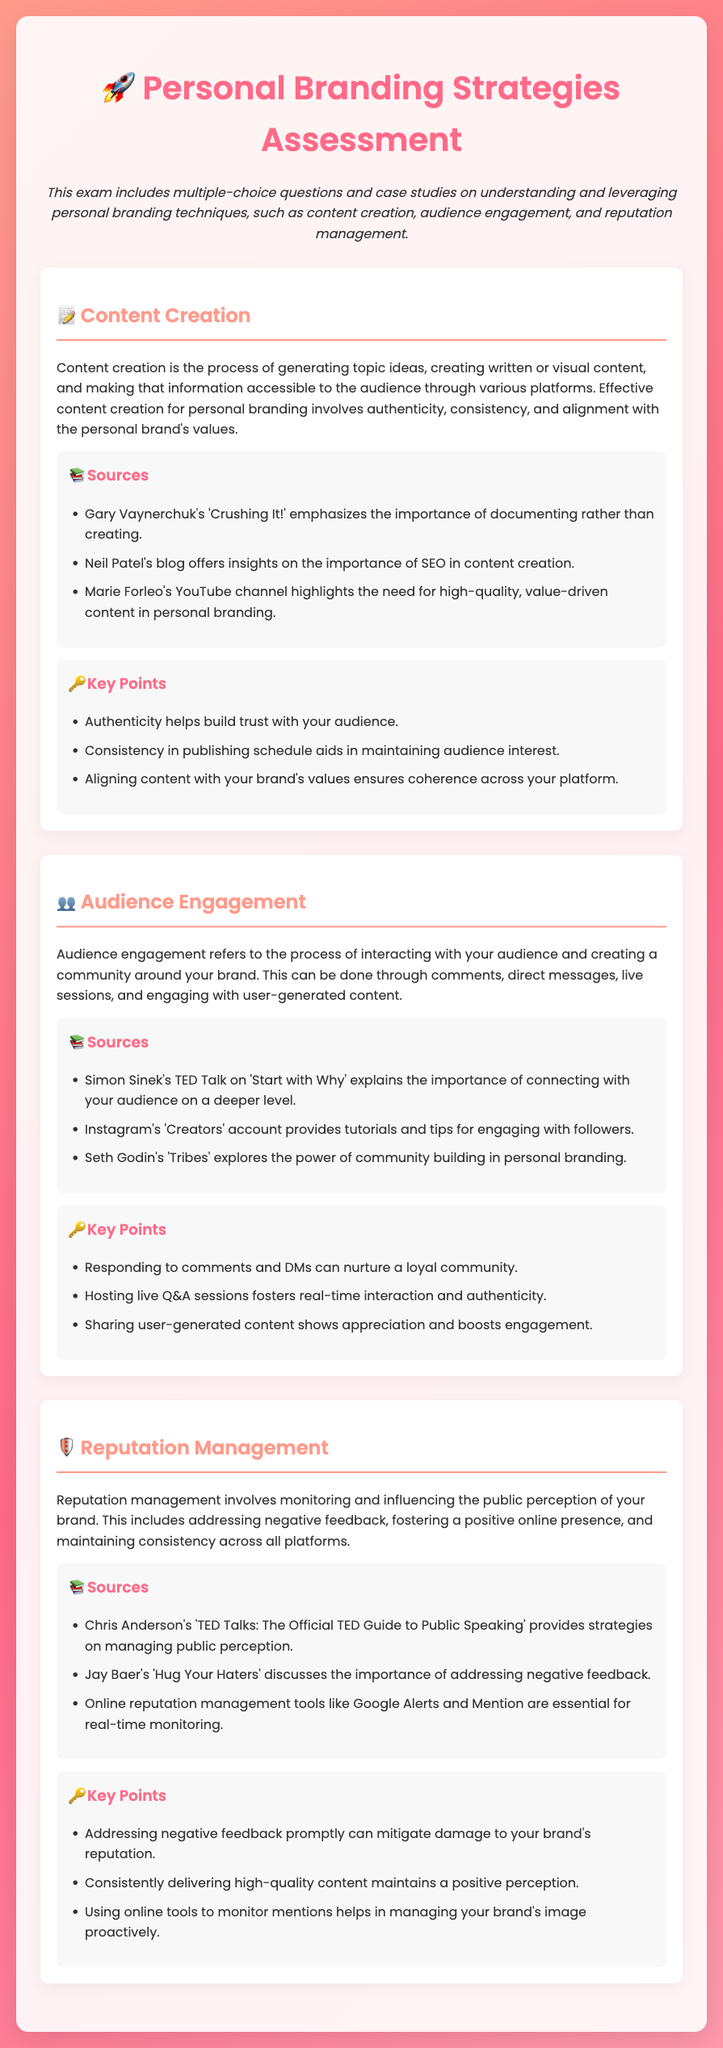What is the title of the assessment? The title appears at the beginning of the document.
Answer: Personal Branding Strategies Assessment What is the primary focus of the document? The document outlines the scope of the assessment, connecting to various branding techniques.
Answer: Personal branding techniques Name one source emphasizing the importance of documenting in content creation. The document lists sources related to content creation strategies.
Answer: Gary Vaynerchuk's 'Crushing It!' What does audience engagement involve? The document provides a definition of audience engagement within its details section.
Answer: Interacting with your audience Which TED Talk is mentioned in relation to connecting with the audience? The document cites a TED Talk that focuses on audience connection.
Answer: Simon Sinek's TED Talk on 'Start with Why' What is one key point about reputation management? The document lists key points related to managing reputation.
Answer: Addressing negative feedback promptly How can you foster real-time interaction with your audience? The document refers to a method of engaging the audience through live sessions.
Answer: Hosting live Q&A sessions What is a tool recommended for online reputation monitoring? The document lists tools for managing public perception and reputation.
Answer: Google Alerts What type of content should align with your brand's values? The document discusses the aspect of aligning content with branding.
Answer: High-quality, value-driven content 